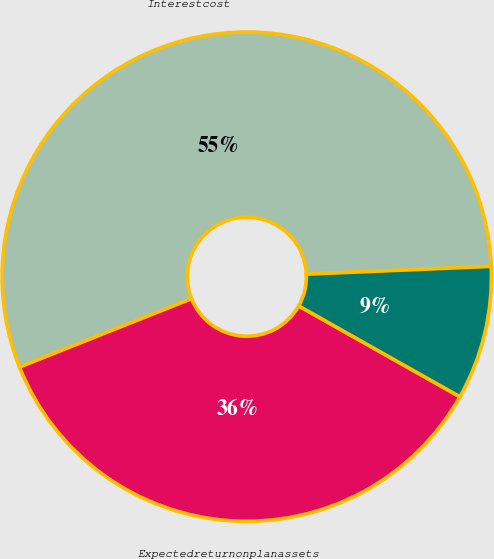Convert chart to OTSL. <chart><loc_0><loc_0><loc_500><loc_500><pie_chart><fcel>Interestcost<fcel>Expectedreturnonplanassets<fcel>Unnamed: 2<nl><fcel>55.35%<fcel>35.81%<fcel>8.84%<nl></chart> 